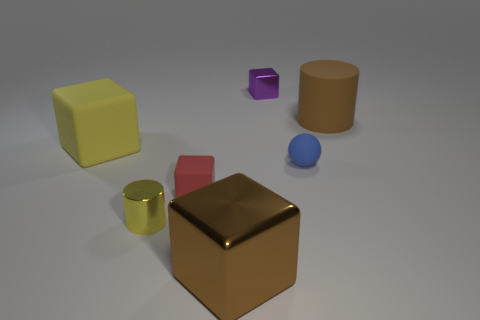Is the color of the big thing in front of the tiny rubber sphere the same as the small matte object that is to the left of the small blue sphere?
Your response must be concise. No. How many spheres are behind the yellow rubber block?
Your response must be concise. 0. There is a large rubber object that is to the left of the big brown thing that is left of the purple thing; is there a large shiny block that is on the left side of it?
Ensure brevity in your answer.  No. How many rubber cylinders have the same size as the purple metal thing?
Offer a very short reply. 0. The big brown object that is on the right side of the metallic cube behind the rubber ball is made of what material?
Give a very brief answer. Rubber. There is a big rubber thing that is to the left of the metal thing that is to the right of the brown object to the left of the tiny matte ball; what is its shape?
Make the answer very short. Cube. Do the brown thing left of the large matte cylinder and the large brown thing behind the yellow metallic cylinder have the same shape?
Your answer should be very brief. No. How many other objects are the same material as the yellow block?
Keep it short and to the point. 3. There is a large thing that is made of the same material as the yellow block; what shape is it?
Offer a very short reply. Cylinder. Is the purple shiny thing the same size as the brown shiny object?
Provide a succinct answer. No. 